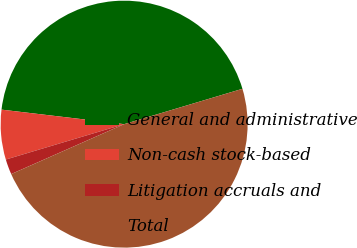Convert chart to OTSL. <chart><loc_0><loc_0><loc_500><loc_500><pie_chart><fcel>General and administrative<fcel>Non-cash stock-based<fcel>Litigation accruals and<fcel>Total<nl><fcel>43.5%<fcel>6.5%<fcel>2.0%<fcel>48.0%<nl></chart> 